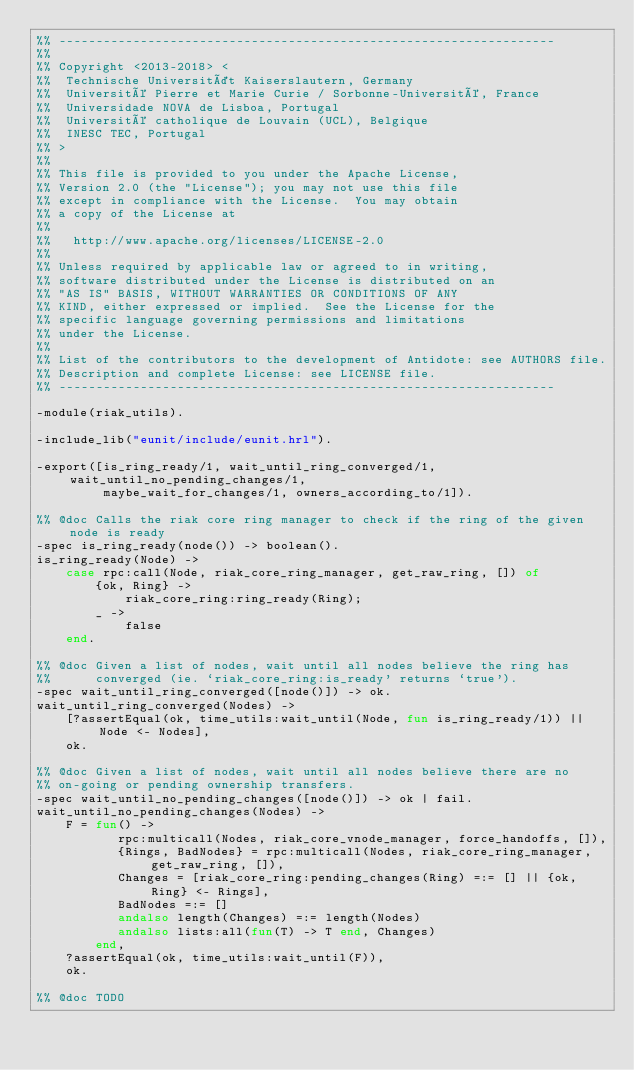Convert code to text. <code><loc_0><loc_0><loc_500><loc_500><_Erlang_>%% -------------------------------------------------------------------
%%
%% Copyright <2013-2018> <
%%  Technische Universität Kaiserslautern, Germany
%%  Université Pierre et Marie Curie / Sorbonne-Université, France
%%  Universidade NOVA de Lisboa, Portugal
%%  Université catholique de Louvain (UCL), Belgique
%%  INESC TEC, Portugal
%% >
%%
%% This file is provided to you under the Apache License,
%% Version 2.0 (the "License"); you may not use this file
%% except in compliance with the License.  You may obtain
%% a copy of the License at
%%
%%   http://www.apache.org/licenses/LICENSE-2.0
%%
%% Unless required by applicable law or agreed to in writing,
%% software distributed under the License is distributed on an
%% "AS IS" BASIS, WITHOUT WARRANTIES OR CONDITIONS OF ANY
%% KIND, either expressed or implied.  See the License for the
%% specific language governing permissions and limitations
%% under the License.
%%
%% List of the contributors to the development of Antidote: see AUTHORS file.
%% Description and complete License: see LICENSE file.
%% -------------------------------------------------------------------

-module(riak_utils).

-include_lib("eunit/include/eunit.hrl").

-export([is_ring_ready/1, wait_until_ring_converged/1, wait_until_no_pending_changes/1,
         maybe_wait_for_changes/1, owners_according_to/1]).

%% @doc Calls the riak core ring manager to check if the ring of the given node is ready
-spec is_ring_ready(node()) -> boolean().
is_ring_ready(Node) ->
    case rpc:call(Node, riak_core_ring_manager, get_raw_ring, []) of
        {ok, Ring} ->
            riak_core_ring:ring_ready(Ring);
        _ ->
            false
    end.

%% @doc Given a list of nodes, wait until all nodes believe the ring has
%%      converged (ie. `riak_core_ring:is_ready' returns `true').
-spec wait_until_ring_converged([node()]) -> ok.
wait_until_ring_converged(Nodes) ->
    [?assertEqual(ok, time_utils:wait_until(Node, fun is_ring_ready/1)) || Node <- Nodes],
    ok.

%% @doc Given a list of nodes, wait until all nodes believe there are no
%% on-going or pending ownership transfers.
-spec wait_until_no_pending_changes([node()]) -> ok | fail.
wait_until_no_pending_changes(Nodes) ->
    F = fun() ->
           rpc:multicall(Nodes, riak_core_vnode_manager, force_handoffs, []),
           {Rings, BadNodes} = rpc:multicall(Nodes, riak_core_ring_manager, get_raw_ring, []),
           Changes = [riak_core_ring:pending_changes(Ring) =:= [] || {ok, Ring} <- Rings],
           BadNodes =:= []
           andalso length(Changes) =:= length(Nodes)
           andalso lists:all(fun(T) -> T end, Changes)
        end,
    ?assertEqual(ok, time_utils:wait_until(F)),
    ok.

%% @doc TODO</code> 